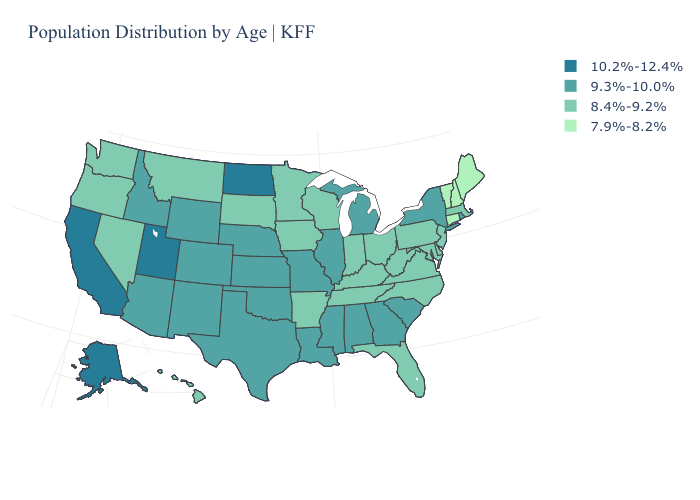Does the map have missing data?
Answer briefly. No. What is the value of Alabama?
Write a very short answer. 9.3%-10.0%. Which states hav the highest value in the South?
Short answer required. Alabama, Georgia, Louisiana, Mississippi, Oklahoma, South Carolina, Texas. Among the states that border Connecticut , which have the lowest value?
Keep it brief. Massachusetts. What is the highest value in the West ?
Keep it brief. 10.2%-12.4%. Among the states that border Montana , which have the highest value?
Keep it brief. North Dakota. Name the states that have a value in the range 9.3%-10.0%?
Write a very short answer. Alabama, Arizona, Colorado, Georgia, Idaho, Illinois, Kansas, Louisiana, Michigan, Mississippi, Missouri, Nebraska, New Mexico, New York, Oklahoma, Rhode Island, South Carolina, Texas, Wyoming. Name the states that have a value in the range 8.4%-9.2%?
Concise answer only. Arkansas, Delaware, Florida, Hawaii, Indiana, Iowa, Kentucky, Maryland, Massachusetts, Minnesota, Montana, Nevada, New Jersey, North Carolina, Ohio, Oregon, Pennsylvania, South Dakota, Tennessee, Virginia, Washington, West Virginia, Wisconsin. Name the states that have a value in the range 7.9%-8.2%?
Write a very short answer. Connecticut, Maine, New Hampshire, Vermont. What is the value of Virginia?
Give a very brief answer. 8.4%-9.2%. What is the value of Texas?
Answer briefly. 9.3%-10.0%. Which states have the lowest value in the USA?
Be succinct. Connecticut, Maine, New Hampshire, Vermont. Does the map have missing data?
Quick response, please. No. What is the value of North Carolina?
Give a very brief answer. 8.4%-9.2%. Does the map have missing data?
Keep it brief. No. 